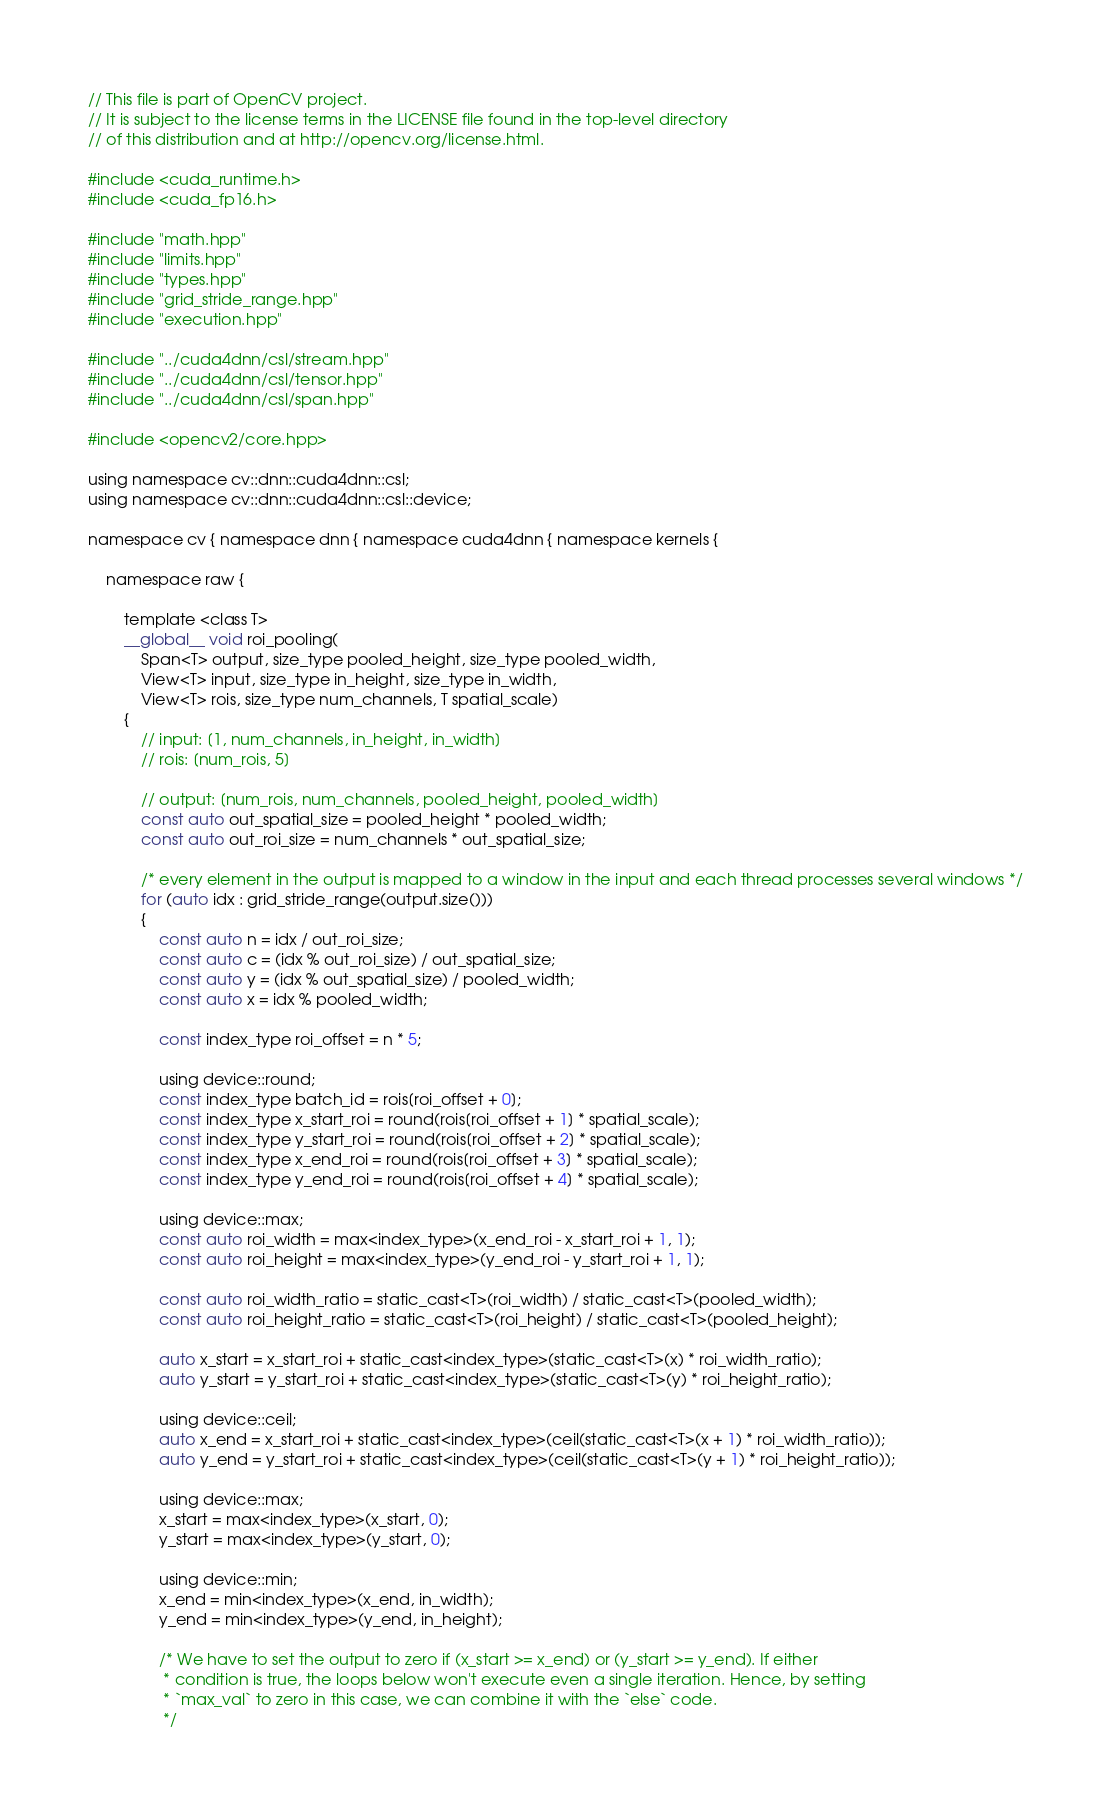<code> <loc_0><loc_0><loc_500><loc_500><_Cuda_>// This file is part of OpenCV project.
// It is subject to the license terms in the LICENSE file found in the top-level directory
// of this distribution and at http://opencv.org/license.html.

#include <cuda_runtime.h>
#include <cuda_fp16.h>

#include "math.hpp"
#include "limits.hpp"
#include "types.hpp"
#include "grid_stride_range.hpp"
#include "execution.hpp"

#include "../cuda4dnn/csl/stream.hpp"
#include "../cuda4dnn/csl/tensor.hpp"
#include "../cuda4dnn/csl/span.hpp"

#include <opencv2/core.hpp>

using namespace cv::dnn::cuda4dnn::csl;
using namespace cv::dnn::cuda4dnn::csl::device;

namespace cv { namespace dnn { namespace cuda4dnn { namespace kernels {

    namespace raw {

        template <class T>
        __global__ void roi_pooling(
            Span<T> output, size_type pooled_height, size_type pooled_width,
            View<T> input, size_type in_height, size_type in_width,
            View<T> rois, size_type num_channels, T spatial_scale)
        {
            // input: [1, num_channels, in_height, in_width]
            // rois: [num_rois, 5]

            // output: [num_rois, num_channels, pooled_height, pooled_width]
            const auto out_spatial_size = pooled_height * pooled_width;
            const auto out_roi_size = num_channels * out_spatial_size;

            /* every element in the output is mapped to a window in the input and each thread processes several windows */
            for (auto idx : grid_stride_range(output.size()))
            {
                const auto n = idx / out_roi_size;
                const auto c = (idx % out_roi_size) / out_spatial_size;
                const auto y = (idx % out_spatial_size) / pooled_width;
                const auto x = idx % pooled_width;

                const index_type roi_offset = n * 5;

                using device::round;
                const index_type batch_id = rois[roi_offset + 0];
                const index_type x_start_roi = round(rois[roi_offset + 1] * spatial_scale);
                const index_type y_start_roi = round(rois[roi_offset + 2] * spatial_scale);
                const index_type x_end_roi = round(rois[roi_offset + 3] * spatial_scale);
                const index_type y_end_roi = round(rois[roi_offset + 4] * spatial_scale);

                using device::max;
                const auto roi_width = max<index_type>(x_end_roi - x_start_roi + 1, 1);
                const auto roi_height = max<index_type>(y_end_roi - y_start_roi + 1, 1);

                const auto roi_width_ratio = static_cast<T>(roi_width) / static_cast<T>(pooled_width);
                const auto roi_height_ratio = static_cast<T>(roi_height) / static_cast<T>(pooled_height);

                auto x_start = x_start_roi + static_cast<index_type>(static_cast<T>(x) * roi_width_ratio);
                auto y_start = y_start_roi + static_cast<index_type>(static_cast<T>(y) * roi_height_ratio);

                using device::ceil;
                auto x_end = x_start_roi + static_cast<index_type>(ceil(static_cast<T>(x + 1) * roi_width_ratio));
                auto y_end = y_start_roi + static_cast<index_type>(ceil(static_cast<T>(y + 1) * roi_height_ratio));

                using device::max;
                x_start = max<index_type>(x_start, 0);
                y_start = max<index_type>(y_start, 0);

                using device::min;
                x_end = min<index_type>(x_end, in_width);
                y_end = min<index_type>(y_end, in_height);

                /* We have to set the output to zero if (x_start >= x_end) or (y_start >= y_end). If either
                 * condition is true, the loops below won't execute even a single iteration. Hence, by setting
                 * `max_val` to zero in this case, we can combine it with the `else` code.
                 */</code> 